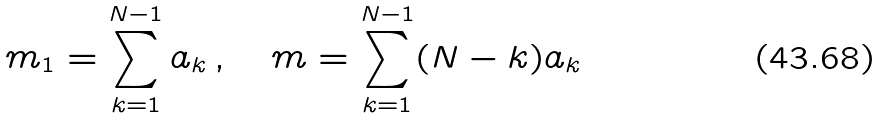<formula> <loc_0><loc_0><loc_500><loc_500>m _ { 1 } = \sum _ { k = 1 } ^ { N - 1 } a _ { k } \, , \quad m = \sum _ { k = 1 } ^ { N - 1 } ( N - k ) a _ { k }</formula> 